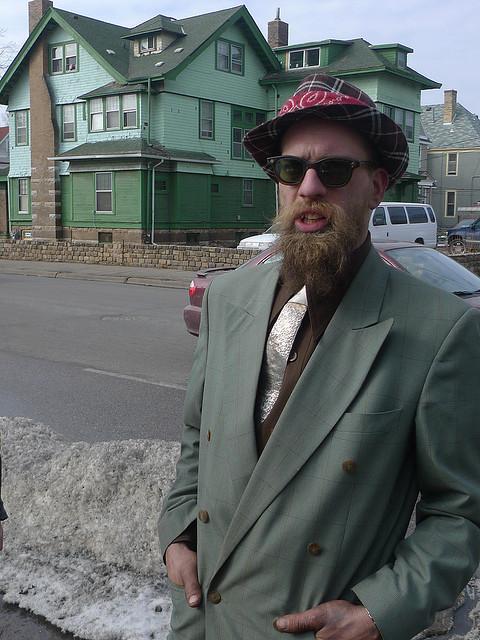How many men are there?
Give a very brief answer. 1. How many people are seen?
Give a very brief answer. 1. How many cars can you see?
Give a very brief answer. 2. 